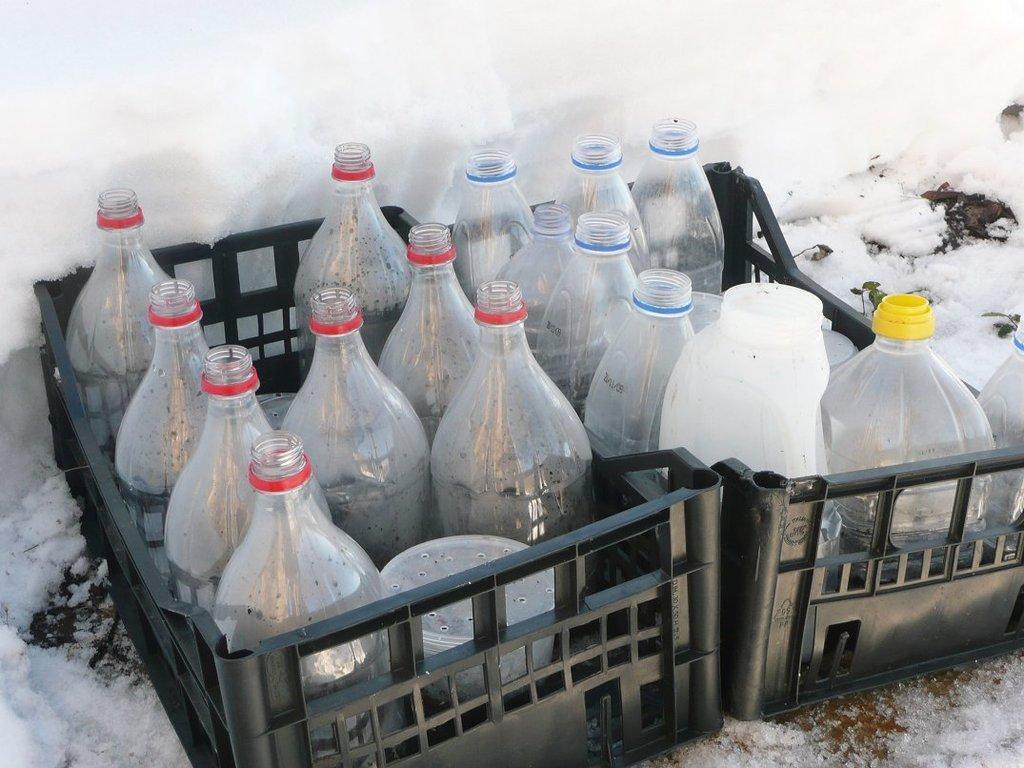Could you give a brief overview of what you see in this image? In this image I can see number of bottles in containers. In the background I can see snow. 